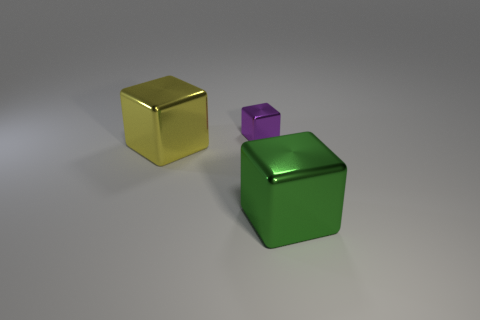There is a cube that is in front of the purple shiny thing and to the right of the yellow metallic thing; what material is it made of?
Offer a very short reply. Metal. Is there a yellow block right of the metal object that is to the left of the tiny purple thing?
Provide a succinct answer. No. There is a cube that is right of the yellow block and to the left of the green metallic block; what size is it?
Make the answer very short. Small. How many green things are shiny cubes or matte spheres?
Offer a very short reply. 1. What is the shape of the yellow shiny object that is the same size as the green thing?
Your answer should be very brief. Cube. What number of other things are the same color as the tiny block?
Offer a terse response. 0. There is a purple cube that is to the left of the big metallic object that is to the right of the tiny purple metal thing; how big is it?
Offer a very short reply. Small. Are the big block that is left of the tiny purple metallic block and the tiny purple block made of the same material?
Make the answer very short. Yes. What shape is the object in front of the yellow metallic block?
Provide a short and direct response. Cube. How many purple cubes are the same size as the yellow shiny cube?
Give a very brief answer. 0. 